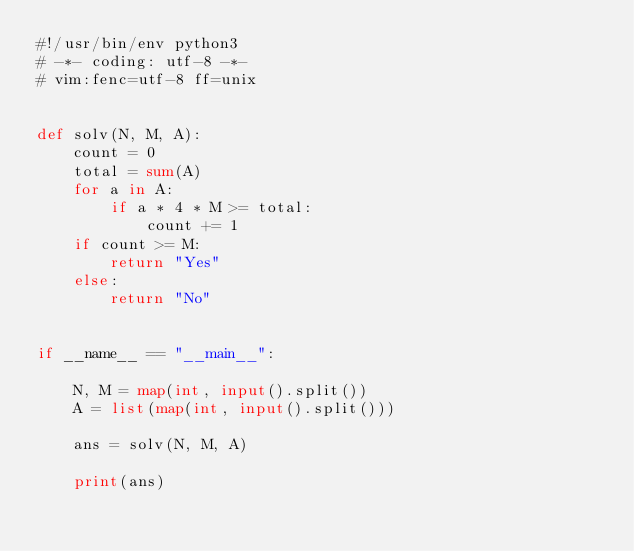<code> <loc_0><loc_0><loc_500><loc_500><_Python_>#!/usr/bin/env python3
# -*- coding: utf-8 -*-
# vim:fenc=utf-8 ff=unix


def solv(N, M, A):
    count = 0
    total = sum(A)
    for a in A:
        if a * 4 * M >= total:
            count += 1
    if count >= M:
        return "Yes"
    else:
        return "No"


if __name__ == "__main__":

    N, M = map(int, input().split())
    A = list(map(int, input().split()))

    ans = solv(N, M, A)

    print(ans)
</code> 